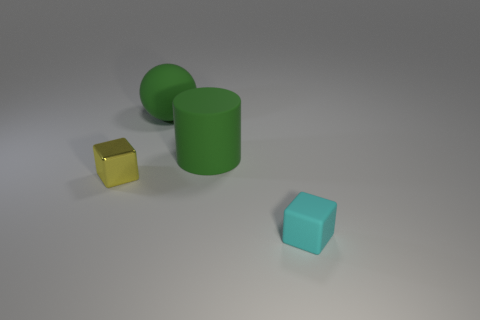Add 4 large green cylinders. How many objects exist? 8 Subtract all cylinders. How many objects are left? 3 Subtract 1 cylinders. How many cylinders are left? 0 Subtract all red spheres. Subtract all brown blocks. How many spheres are left? 1 Subtract all blue spheres. How many yellow cubes are left? 1 Subtract all big cylinders. Subtract all large green balls. How many objects are left? 2 Add 4 cyan matte cubes. How many cyan matte cubes are left? 5 Add 4 large red matte balls. How many large red matte balls exist? 4 Subtract 0 purple cubes. How many objects are left? 4 